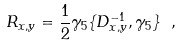Convert formula to latex. <formula><loc_0><loc_0><loc_500><loc_500>R _ { x , y } = \frac { 1 } { 2 } \gamma _ { 5 } \{ D ^ { - 1 } _ { x , y } , \gamma _ { 5 } \} \ ,</formula> 